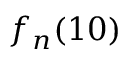<formula> <loc_0><loc_0><loc_500><loc_500>{ f _ { n } } ( 1 0 )</formula> 